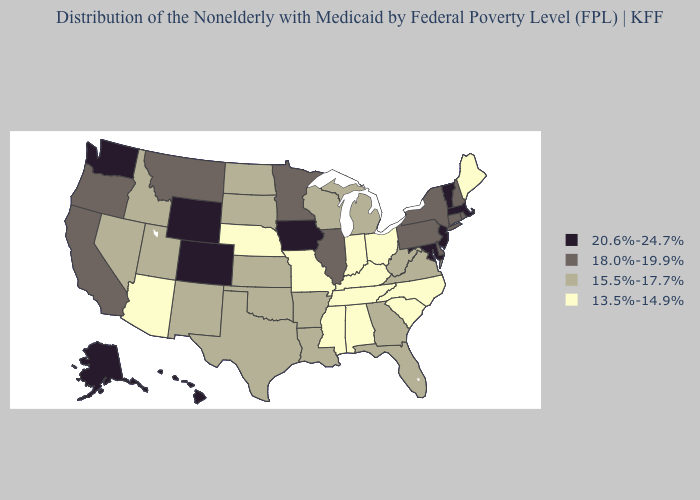Does New Hampshire have the lowest value in the Northeast?
Short answer required. No. Which states hav the highest value in the West?
Keep it brief. Alaska, Colorado, Hawaii, Washington, Wyoming. Does Montana have the lowest value in the West?
Concise answer only. No. What is the value of Virginia?
Quick response, please. 15.5%-17.7%. Among the states that border New Mexico , does Texas have the lowest value?
Answer briefly. No. What is the value of Wisconsin?
Concise answer only. 15.5%-17.7%. Name the states that have a value in the range 15.5%-17.7%?
Give a very brief answer. Arkansas, Florida, Georgia, Idaho, Kansas, Louisiana, Michigan, Nevada, New Mexico, North Dakota, Oklahoma, South Dakota, Texas, Utah, Virginia, West Virginia, Wisconsin. Among the states that border West Virginia , which have the lowest value?
Give a very brief answer. Kentucky, Ohio. Among the states that border Idaho , which have the lowest value?
Short answer required. Nevada, Utah. What is the lowest value in states that border Massachusetts?
Answer briefly. 18.0%-19.9%. What is the highest value in the MidWest ?
Be succinct. 20.6%-24.7%. Does Missouri have the lowest value in the USA?
Be succinct. Yes. Among the states that border Wyoming , does Nebraska have the highest value?
Quick response, please. No. What is the highest value in the USA?
Be succinct. 20.6%-24.7%. 